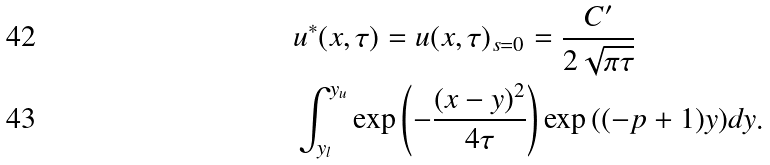Convert formula to latex. <formula><loc_0><loc_0><loc_500><loc_500>& u ^ { * } ( x , \tau ) = u ( x , \tau ) _ { s = 0 } = \frac { C ^ { \prime } } { 2 \sqrt { \pi \tau } } \\ & \int _ { y _ { l } } ^ { y _ { u } } \exp \left ( - \frac { ( x - y ) ^ { 2 } } { 4 \tau } \right ) \exp { \left ( ( - p + 1 ) y \right ) } d y .</formula> 